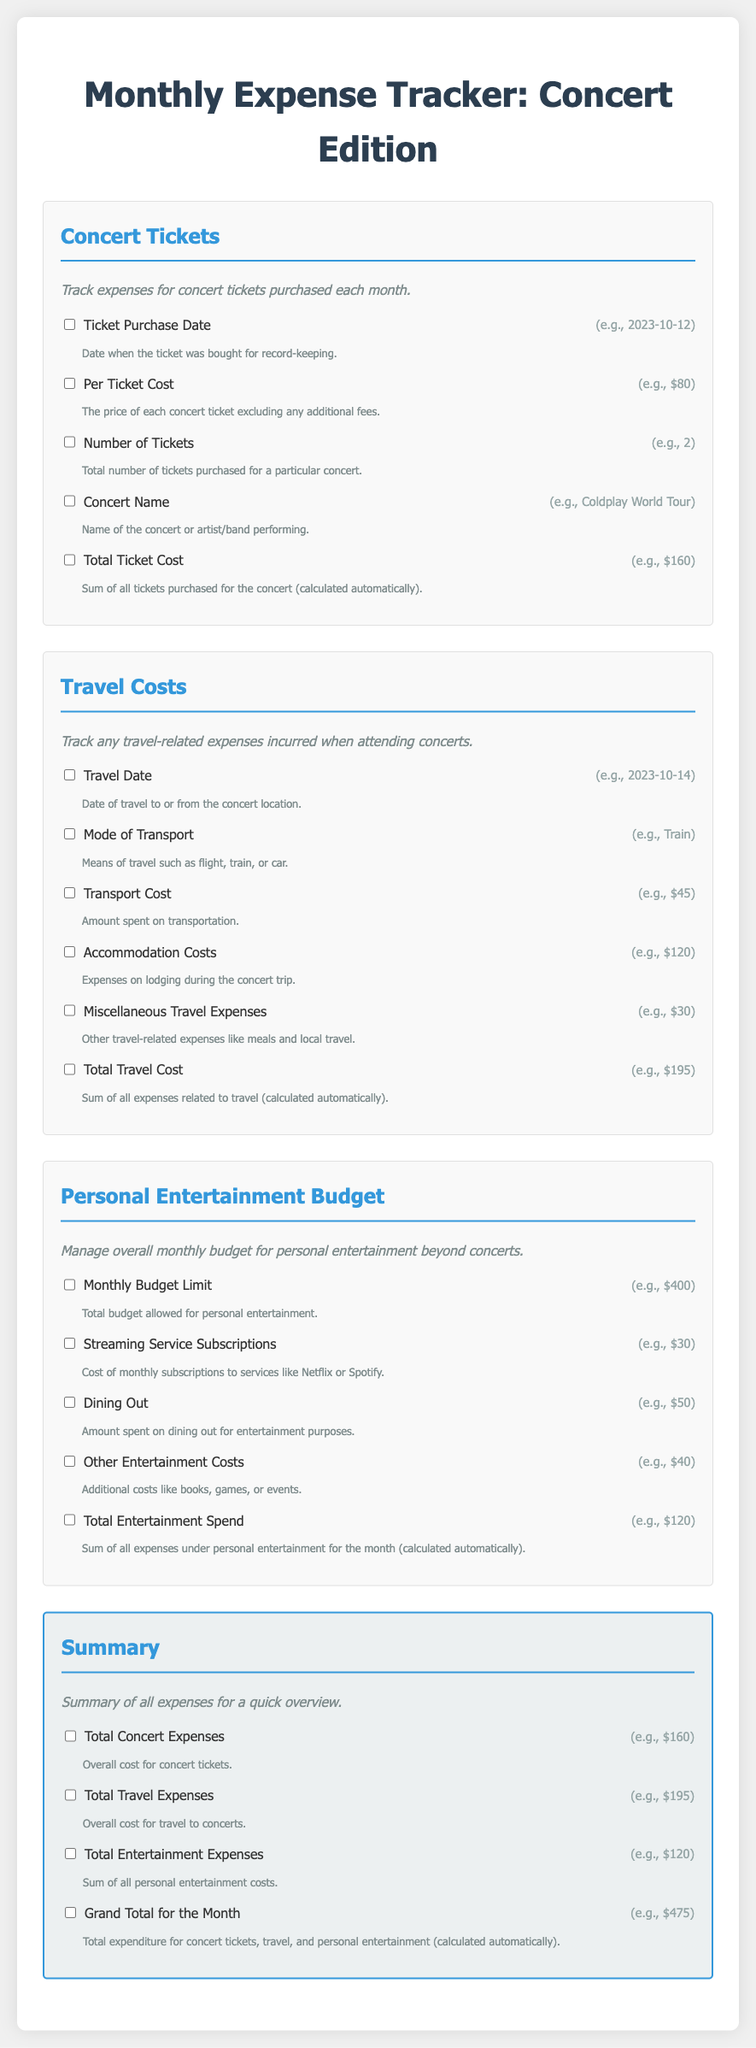what is the title of the document? The title of the document is prominently displayed at the top of the page, which is "Monthly Expense Tracker: Concert Edition".
Answer: Monthly Expense Tracker: Concert Edition how many sections are in the document? The document has four main sections: Concert Tickets, Travel Costs, Personal Entertainment Budget, and Summary.
Answer: 4 what is the cost of one concert ticket? The document specifies that the per ticket cost is an example amount of $80.
Answer: $80 what is the total travel cost example? The total travel cost is presented as an automatic calculation based on expenses, which is $195.
Answer: $195 what does the summary section include? The summary section includes total expenses for concert, travel, and personal entertainment, giving a quick overview of expenditures.
Answer: Total expenses for concert, travel, and personal entertainment what is the mode of transport mentioned in the travel costs section? An example mode of transport listed in the travel costs section is "Train".
Answer: Train how much is the monthly budget limit for entertainment? The suggested monthly budget limit for personal entertainment is stated to be $400.
Answer: $400 what is the total entertainment spend example? The total entertainment spend calculated is shown as $120 in the document.
Answer: $120 what is included under miscellaneous travel expenses? Miscellaneous travel expenses include other costs such as meals and local travel.
Answer: Meals and local travel 